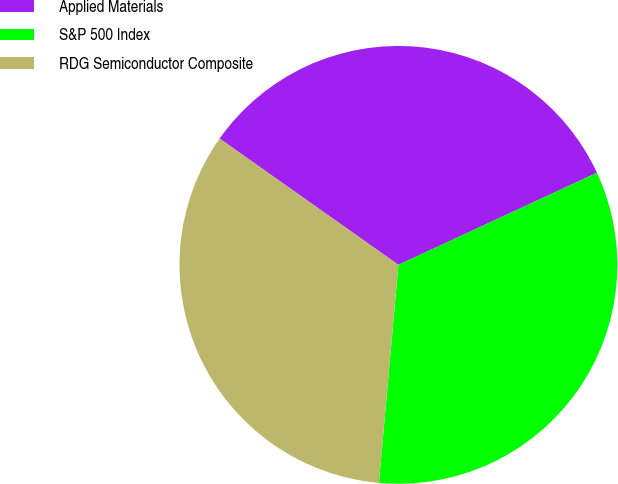Convert chart. <chart><loc_0><loc_0><loc_500><loc_500><pie_chart><fcel>Applied Materials<fcel>S&P 500 Index<fcel>RDG Semiconductor Composite<nl><fcel>33.3%<fcel>33.33%<fcel>33.37%<nl></chart> 